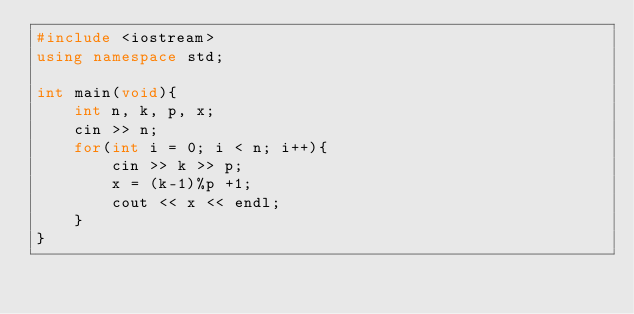Convert code to text. <code><loc_0><loc_0><loc_500><loc_500><_C++_>#include <iostream>
using namespace std;

int main(void){
    int n, k, p, x;
    cin >> n;
    for(int i = 0; i < n; i++){
        cin >> k >> p;
        x = (k-1)%p +1;
        cout << x << endl;
    }
}

</code> 